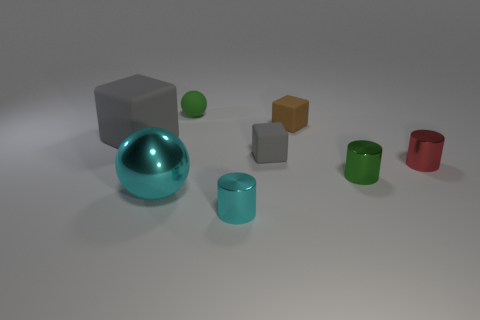Subtract all large gray matte blocks. How many blocks are left? 2 Subtract all blocks. How many objects are left? 5 Subtract all brown cylinders. Subtract all blue spheres. How many cylinders are left? 3 Subtract all yellow cylinders. How many brown spheres are left? 0 Subtract all cyan objects. Subtract all tiny red shiny objects. How many objects are left? 5 Add 6 big matte things. How many big matte things are left? 7 Add 8 brown blocks. How many brown blocks exist? 9 Add 2 big metal things. How many objects exist? 10 Subtract all brown cubes. How many cubes are left? 2 Subtract 1 red cylinders. How many objects are left? 7 